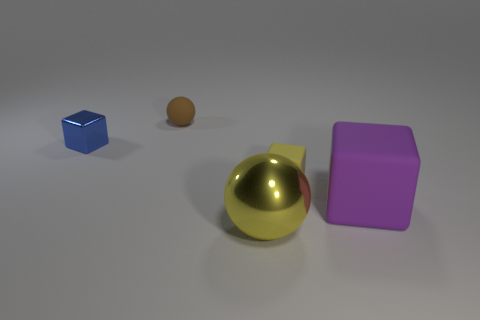How many other things are there of the same material as the tiny sphere?
Give a very brief answer. 2. Are there any other things that have the same shape as the large purple object?
Your answer should be very brief. Yes. What color is the small metallic thing that is the same shape as the tiny yellow matte thing?
Offer a terse response. Blue. Do the shiny thing to the left of the brown matte ball and the big yellow shiny thing have the same size?
Provide a short and direct response. No. What is the size of the metallic object that is in front of the large thing that is on the right side of the small yellow cube?
Ensure brevity in your answer.  Large. Does the tiny blue thing have the same material as the small thing that is on the right side of the brown matte sphere?
Ensure brevity in your answer.  No. Is the number of large rubber blocks that are behind the big block less than the number of tiny brown matte things that are in front of the small blue metallic block?
Your answer should be very brief. No. What is the color of the small sphere that is made of the same material as the purple thing?
Keep it short and to the point. Brown. There is a sphere that is to the left of the large yellow metallic sphere; are there any large matte objects behind it?
Keep it short and to the point. No. What color is the metallic thing that is the same size as the yellow rubber object?
Make the answer very short. Blue. 